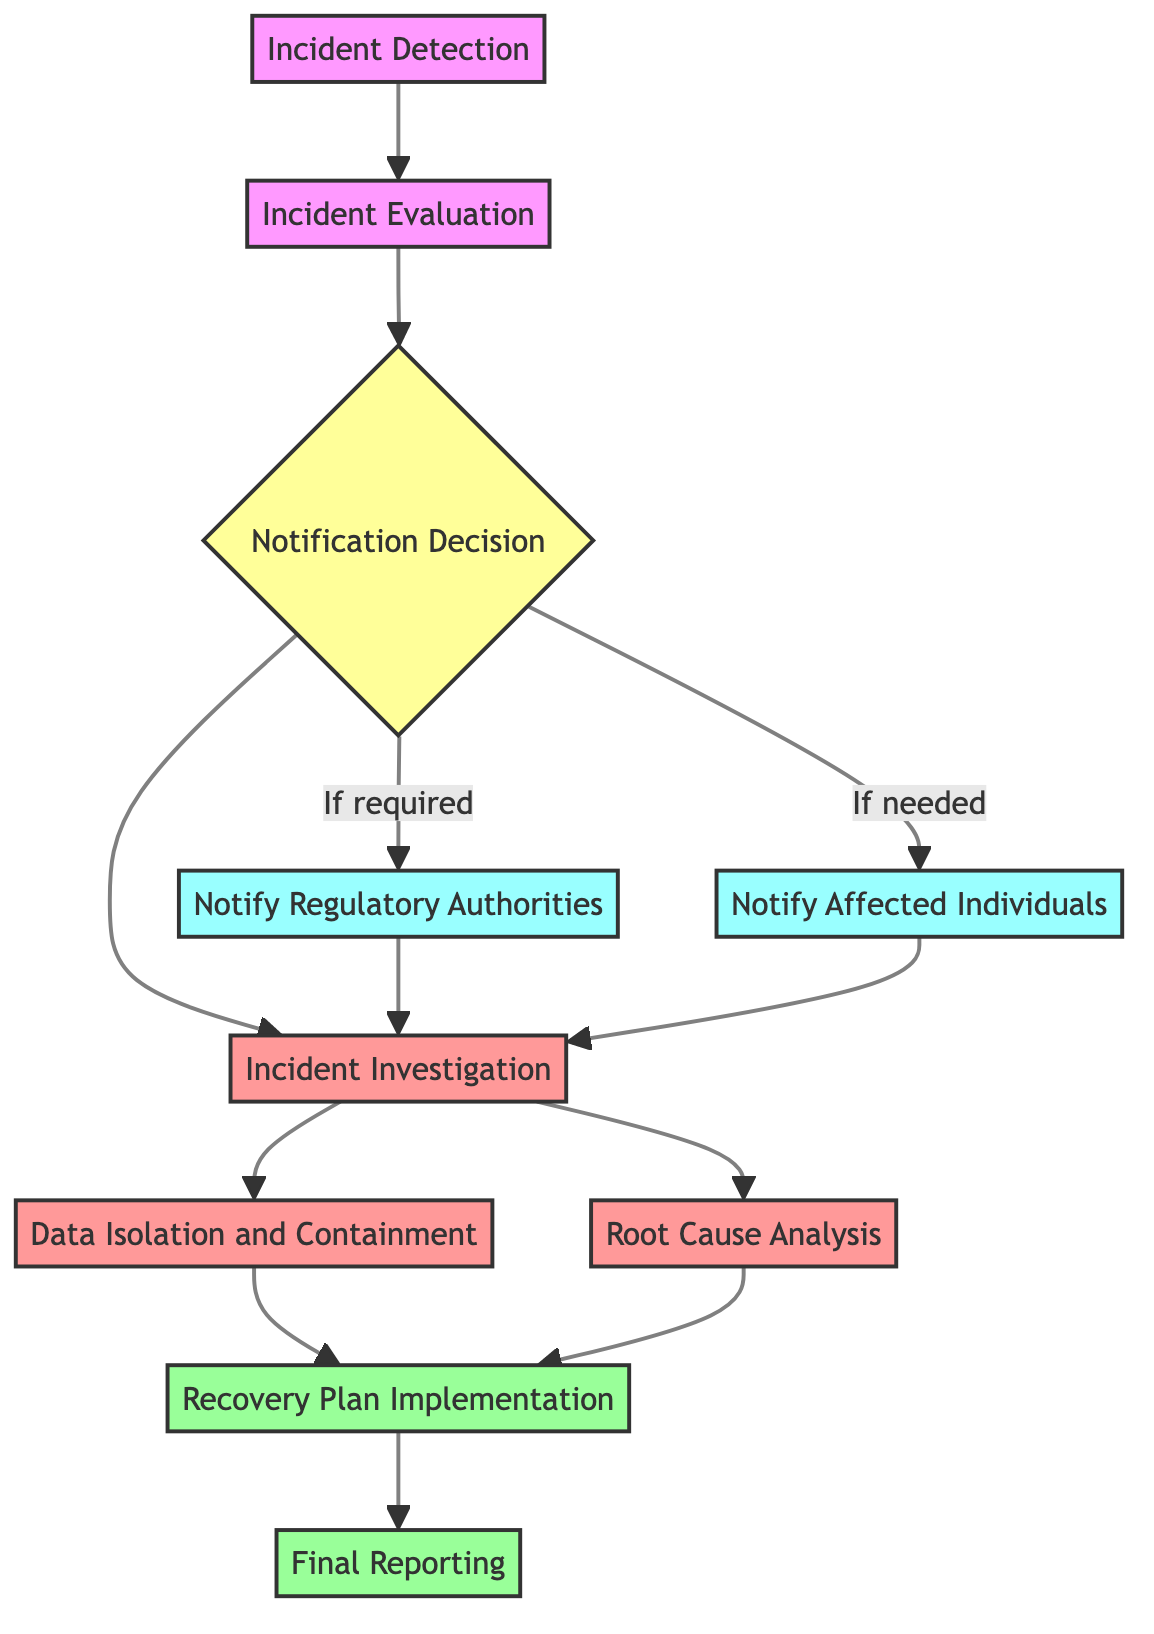What is the first step in the data breach response process? The first step in the response process is "Incident Detection," where the organization identifies a potential data breach event.
Answer: Incident Detection How many outgoing connections does "Incident Evaluation" have? "Incident Evaluation" has one outgoing connection leading to "Notification Decision," which has three outgoing connections. Thus, it has one outgoing connection.
Answer: 1 What happens after "Notification Decision"? After "Notification Decision," the diagram shows three possible outgoing connections: one to "Notify Regulatory Authorities," one to "Notify Affected Individuals," and one to "Incident Investigation."
Answer: Notify Regulatory Authorities, Notify Affected Individuals, Incident Investigation Which stage involves generating a comprehensive report? The stage that involves generating a comprehensive report is "Final Reporting," which is the last step in the breach response process, showing the conclusion of the investigation.
Answer: Final Reporting What are the two procedures that proceed from "Incident Investigation"? From "Incident Investigation," the two procedures are "Data Isolation and Containment" and "Root Cause Analysis," both of which help address the breach effectively.
Answer: Data Isolation and Containment, Root Cause Analysis What is the time frame for notifying regulatory authorities? The time frame to notify regulatory authorities as indicated in the diagram is within 72 hours of the breach detection.
Answer: 72 hours Which node leads directly to "Recovery Plan Implementation"? Both "Data Isolation and Containment" and "Root Cause Analysis" lead directly to "Recovery Plan Implementation" as essential steps in the recovery process.
Answer: Data Isolation and Containment, Root Cause Analysis What is the last step in the data breach response process? The last step in the data breach response process as illustrated in the diagram is "Final Reporting," indicating the completion of the response efforts.
Answer: Final Reporting How many total stages are there in the data breach response process? Counting all the nodes in the diagram—there are ten distinct stages that form the complete process from detection to final reporting.
Answer: 10 What action is taken before initiating "Incident Investigation"? Before initiating "Incident Investigation," the organization must decide to notify either the regulatory authorities or affected individuals based on "Notification Decision."
Answer: Notification Decision 